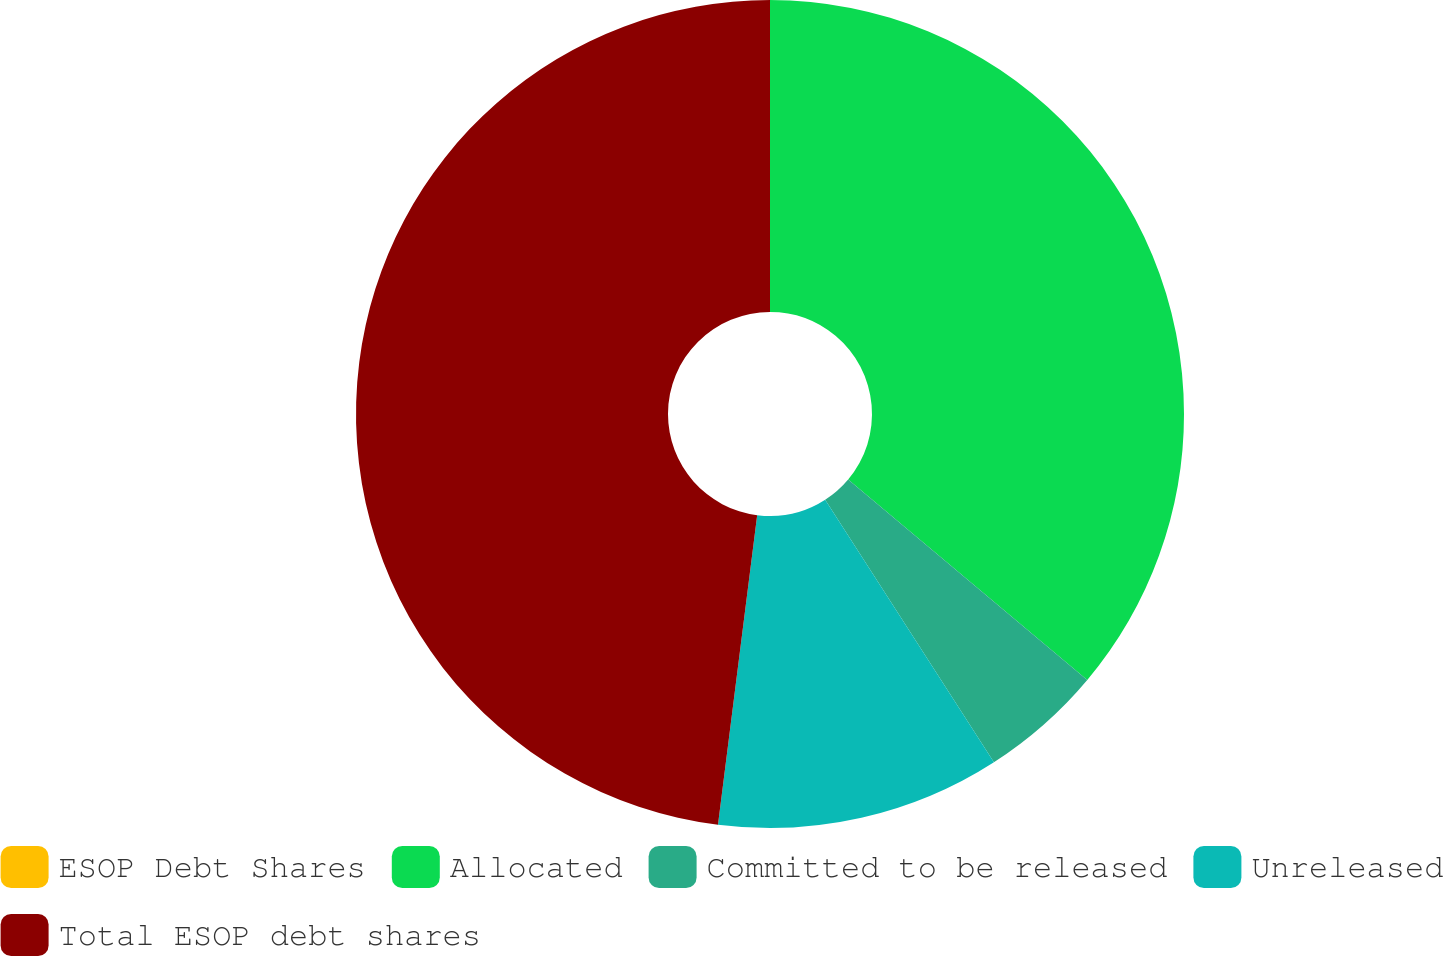Convert chart to OTSL. <chart><loc_0><loc_0><loc_500><loc_500><pie_chart><fcel>ESOP Debt Shares<fcel>Allocated<fcel>Committed to be released<fcel>Unreleased<fcel>Total ESOP debt shares<nl><fcel>0.0%<fcel>36.1%<fcel>4.8%<fcel>11.1%<fcel>47.99%<nl></chart> 